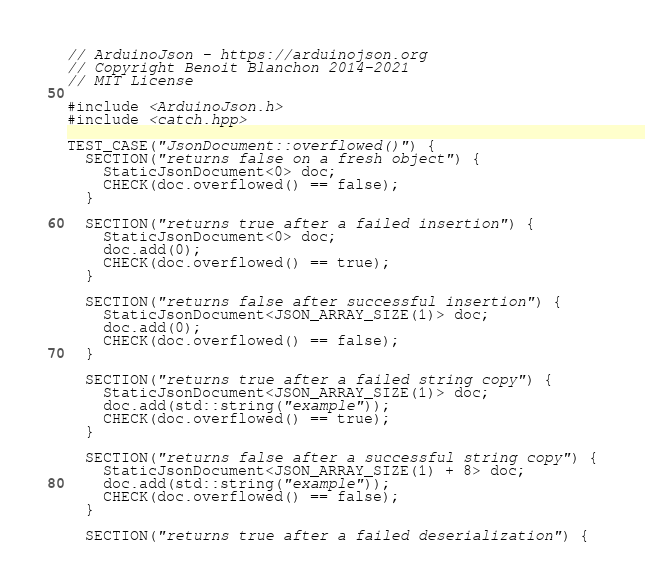Convert code to text. <code><loc_0><loc_0><loc_500><loc_500><_C++_>// ArduinoJson - https://arduinojson.org
// Copyright Benoit Blanchon 2014-2021
// MIT License

#include <ArduinoJson.h>
#include <catch.hpp>

TEST_CASE("JsonDocument::overflowed()") {
  SECTION("returns false on a fresh object") {
    StaticJsonDocument<0> doc;
    CHECK(doc.overflowed() == false);
  }

  SECTION("returns true after a failed insertion") {
    StaticJsonDocument<0> doc;
    doc.add(0);
    CHECK(doc.overflowed() == true);
  }

  SECTION("returns false after successful insertion") {
    StaticJsonDocument<JSON_ARRAY_SIZE(1)> doc;
    doc.add(0);
    CHECK(doc.overflowed() == false);
  }

  SECTION("returns true after a failed string copy") {
    StaticJsonDocument<JSON_ARRAY_SIZE(1)> doc;
    doc.add(std::string("example"));
    CHECK(doc.overflowed() == true);
  }

  SECTION("returns false after a successful string copy") {
    StaticJsonDocument<JSON_ARRAY_SIZE(1) + 8> doc;
    doc.add(std::string("example"));
    CHECK(doc.overflowed() == false);
  }

  SECTION("returns true after a failed deserialization") {</code> 